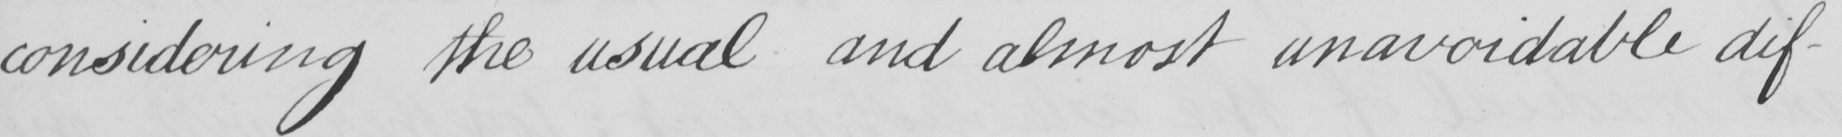Can you read and transcribe this handwriting? considering the usual and almost unavoidable dif- 